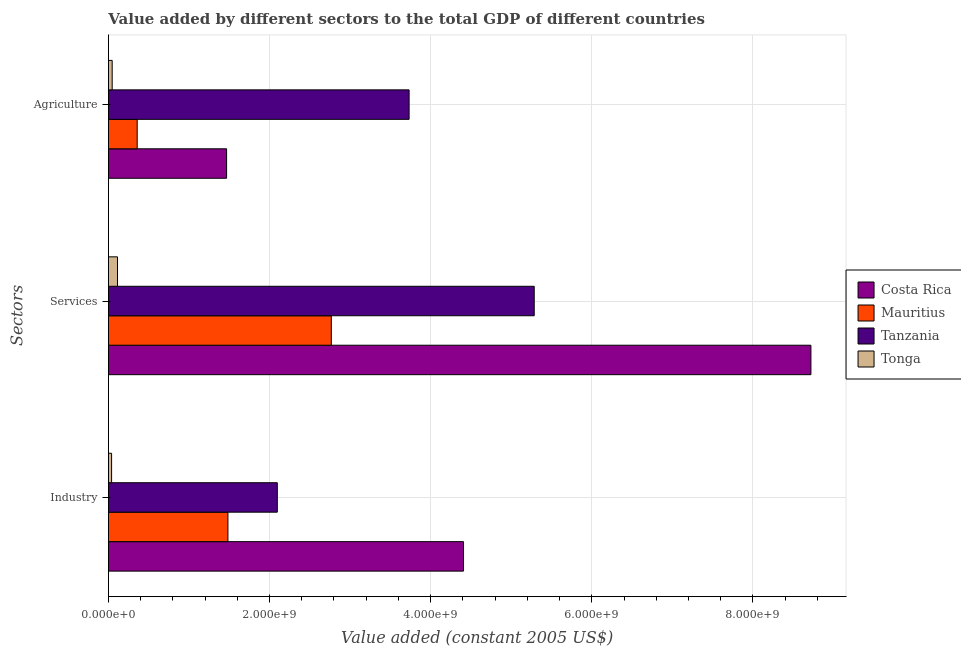How many different coloured bars are there?
Make the answer very short. 4. How many groups of bars are there?
Your response must be concise. 3. Are the number of bars per tick equal to the number of legend labels?
Provide a succinct answer. Yes. Are the number of bars on each tick of the Y-axis equal?
Give a very brief answer. Yes. How many bars are there on the 3rd tick from the top?
Your answer should be compact. 4. How many bars are there on the 3rd tick from the bottom?
Keep it short and to the point. 4. What is the label of the 2nd group of bars from the top?
Give a very brief answer. Services. What is the value added by services in Tanzania?
Ensure brevity in your answer.  5.29e+09. Across all countries, what is the maximum value added by industrial sector?
Give a very brief answer. 4.41e+09. Across all countries, what is the minimum value added by agricultural sector?
Keep it short and to the point. 4.65e+07. In which country was the value added by agricultural sector maximum?
Make the answer very short. Tanzania. In which country was the value added by services minimum?
Your answer should be very brief. Tonga. What is the total value added by industrial sector in the graph?
Make the answer very short. 8.03e+09. What is the difference between the value added by services in Mauritius and that in Tonga?
Your answer should be very brief. 2.65e+09. What is the difference between the value added by services in Mauritius and the value added by industrial sector in Costa Rica?
Offer a very short reply. -1.64e+09. What is the average value added by industrial sector per country?
Your response must be concise. 2.01e+09. What is the difference between the value added by services and value added by agricultural sector in Tonga?
Ensure brevity in your answer.  6.60e+07. In how many countries, is the value added by services greater than 1200000000 US$?
Ensure brevity in your answer.  3. What is the ratio of the value added by services in Costa Rica to that in Tonga?
Offer a terse response. 77.46. Is the value added by industrial sector in Mauritius less than that in Tonga?
Give a very brief answer. No. What is the difference between the highest and the second highest value added by services?
Your answer should be compact. 3.43e+09. What is the difference between the highest and the lowest value added by industrial sector?
Provide a short and direct response. 4.37e+09. In how many countries, is the value added by services greater than the average value added by services taken over all countries?
Your response must be concise. 2. What does the 2nd bar from the bottom in Services represents?
Provide a succinct answer. Mauritius. Is it the case that in every country, the sum of the value added by industrial sector and value added by services is greater than the value added by agricultural sector?
Offer a very short reply. Yes. How many bars are there?
Provide a succinct answer. 12. Are all the bars in the graph horizontal?
Provide a succinct answer. Yes. Where does the legend appear in the graph?
Your response must be concise. Center right. How are the legend labels stacked?
Make the answer very short. Vertical. What is the title of the graph?
Your response must be concise. Value added by different sectors to the total GDP of different countries. What is the label or title of the X-axis?
Provide a succinct answer. Value added (constant 2005 US$). What is the label or title of the Y-axis?
Make the answer very short. Sectors. What is the Value added (constant 2005 US$) of Costa Rica in Industry?
Your answer should be compact. 4.41e+09. What is the Value added (constant 2005 US$) of Mauritius in Industry?
Your response must be concise. 1.48e+09. What is the Value added (constant 2005 US$) in Tanzania in Industry?
Provide a short and direct response. 2.10e+09. What is the Value added (constant 2005 US$) of Tonga in Industry?
Make the answer very short. 3.93e+07. What is the Value added (constant 2005 US$) of Costa Rica in Services?
Provide a succinct answer. 8.72e+09. What is the Value added (constant 2005 US$) in Mauritius in Services?
Ensure brevity in your answer.  2.77e+09. What is the Value added (constant 2005 US$) in Tanzania in Services?
Your answer should be very brief. 5.29e+09. What is the Value added (constant 2005 US$) of Tonga in Services?
Make the answer very short. 1.13e+08. What is the Value added (constant 2005 US$) of Costa Rica in Agriculture?
Your answer should be very brief. 1.47e+09. What is the Value added (constant 2005 US$) of Mauritius in Agriculture?
Your response must be concise. 3.57e+08. What is the Value added (constant 2005 US$) of Tanzania in Agriculture?
Your response must be concise. 3.73e+09. What is the Value added (constant 2005 US$) of Tonga in Agriculture?
Offer a terse response. 4.65e+07. Across all Sectors, what is the maximum Value added (constant 2005 US$) in Costa Rica?
Ensure brevity in your answer.  8.72e+09. Across all Sectors, what is the maximum Value added (constant 2005 US$) in Mauritius?
Your answer should be very brief. 2.77e+09. Across all Sectors, what is the maximum Value added (constant 2005 US$) of Tanzania?
Offer a terse response. 5.29e+09. Across all Sectors, what is the maximum Value added (constant 2005 US$) in Tonga?
Give a very brief answer. 1.13e+08. Across all Sectors, what is the minimum Value added (constant 2005 US$) of Costa Rica?
Your answer should be very brief. 1.47e+09. Across all Sectors, what is the minimum Value added (constant 2005 US$) of Mauritius?
Ensure brevity in your answer.  3.57e+08. Across all Sectors, what is the minimum Value added (constant 2005 US$) of Tanzania?
Your answer should be compact. 2.10e+09. Across all Sectors, what is the minimum Value added (constant 2005 US$) of Tonga?
Your answer should be compact. 3.93e+07. What is the total Value added (constant 2005 US$) in Costa Rica in the graph?
Offer a very short reply. 1.46e+1. What is the total Value added (constant 2005 US$) in Mauritius in the graph?
Offer a very short reply. 4.61e+09. What is the total Value added (constant 2005 US$) of Tanzania in the graph?
Make the answer very short. 1.11e+1. What is the total Value added (constant 2005 US$) in Tonga in the graph?
Provide a succinct answer. 1.98e+08. What is the difference between the Value added (constant 2005 US$) in Costa Rica in Industry and that in Services?
Make the answer very short. -4.31e+09. What is the difference between the Value added (constant 2005 US$) in Mauritius in Industry and that in Services?
Ensure brevity in your answer.  -1.28e+09. What is the difference between the Value added (constant 2005 US$) of Tanzania in Industry and that in Services?
Keep it short and to the point. -3.19e+09. What is the difference between the Value added (constant 2005 US$) of Tonga in Industry and that in Services?
Offer a very short reply. -7.33e+07. What is the difference between the Value added (constant 2005 US$) in Costa Rica in Industry and that in Agriculture?
Provide a succinct answer. 2.94e+09. What is the difference between the Value added (constant 2005 US$) of Mauritius in Industry and that in Agriculture?
Ensure brevity in your answer.  1.13e+09. What is the difference between the Value added (constant 2005 US$) of Tanzania in Industry and that in Agriculture?
Provide a succinct answer. -1.64e+09. What is the difference between the Value added (constant 2005 US$) of Tonga in Industry and that in Agriculture?
Offer a very short reply. -7.25e+06. What is the difference between the Value added (constant 2005 US$) in Costa Rica in Services and that in Agriculture?
Your answer should be very brief. 7.25e+09. What is the difference between the Value added (constant 2005 US$) of Mauritius in Services and that in Agriculture?
Keep it short and to the point. 2.41e+09. What is the difference between the Value added (constant 2005 US$) of Tanzania in Services and that in Agriculture?
Offer a terse response. 1.55e+09. What is the difference between the Value added (constant 2005 US$) of Tonga in Services and that in Agriculture?
Provide a short and direct response. 6.60e+07. What is the difference between the Value added (constant 2005 US$) in Costa Rica in Industry and the Value added (constant 2005 US$) in Mauritius in Services?
Provide a short and direct response. 1.64e+09. What is the difference between the Value added (constant 2005 US$) of Costa Rica in Industry and the Value added (constant 2005 US$) of Tanzania in Services?
Keep it short and to the point. -8.78e+08. What is the difference between the Value added (constant 2005 US$) in Costa Rica in Industry and the Value added (constant 2005 US$) in Tonga in Services?
Offer a terse response. 4.30e+09. What is the difference between the Value added (constant 2005 US$) in Mauritius in Industry and the Value added (constant 2005 US$) in Tanzania in Services?
Ensure brevity in your answer.  -3.80e+09. What is the difference between the Value added (constant 2005 US$) of Mauritius in Industry and the Value added (constant 2005 US$) of Tonga in Services?
Provide a short and direct response. 1.37e+09. What is the difference between the Value added (constant 2005 US$) in Tanzania in Industry and the Value added (constant 2005 US$) in Tonga in Services?
Ensure brevity in your answer.  1.98e+09. What is the difference between the Value added (constant 2005 US$) of Costa Rica in Industry and the Value added (constant 2005 US$) of Mauritius in Agriculture?
Keep it short and to the point. 4.05e+09. What is the difference between the Value added (constant 2005 US$) in Costa Rica in Industry and the Value added (constant 2005 US$) in Tanzania in Agriculture?
Offer a very short reply. 6.75e+08. What is the difference between the Value added (constant 2005 US$) in Costa Rica in Industry and the Value added (constant 2005 US$) in Tonga in Agriculture?
Offer a terse response. 4.36e+09. What is the difference between the Value added (constant 2005 US$) in Mauritius in Industry and the Value added (constant 2005 US$) in Tanzania in Agriculture?
Your response must be concise. -2.25e+09. What is the difference between the Value added (constant 2005 US$) of Mauritius in Industry and the Value added (constant 2005 US$) of Tonga in Agriculture?
Ensure brevity in your answer.  1.44e+09. What is the difference between the Value added (constant 2005 US$) in Tanzania in Industry and the Value added (constant 2005 US$) in Tonga in Agriculture?
Provide a succinct answer. 2.05e+09. What is the difference between the Value added (constant 2005 US$) of Costa Rica in Services and the Value added (constant 2005 US$) of Mauritius in Agriculture?
Provide a succinct answer. 8.36e+09. What is the difference between the Value added (constant 2005 US$) of Costa Rica in Services and the Value added (constant 2005 US$) of Tanzania in Agriculture?
Give a very brief answer. 4.99e+09. What is the difference between the Value added (constant 2005 US$) of Costa Rica in Services and the Value added (constant 2005 US$) of Tonga in Agriculture?
Your answer should be compact. 8.67e+09. What is the difference between the Value added (constant 2005 US$) of Mauritius in Services and the Value added (constant 2005 US$) of Tanzania in Agriculture?
Your response must be concise. -9.66e+08. What is the difference between the Value added (constant 2005 US$) in Mauritius in Services and the Value added (constant 2005 US$) in Tonga in Agriculture?
Provide a short and direct response. 2.72e+09. What is the difference between the Value added (constant 2005 US$) of Tanzania in Services and the Value added (constant 2005 US$) of Tonga in Agriculture?
Keep it short and to the point. 5.24e+09. What is the average Value added (constant 2005 US$) of Costa Rica per Sectors?
Provide a short and direct response. 4.86e+09. What is the average Value added (constant 2005 US$) of Mauritius per Sectors?
Make the answer very short. 1.54e+09. What is the average Value added (constant 2005 US$) in Tanzania per Sectors?
Provide a short and direct response. 3.70e+09. What is the average Value added (constant 2005 US$) of Tonga per Sectors?
Ensure brevity in your answer.  6.61e+07. What is the difference between the Value added (constant 2005 US$) in Costa Rica and Value added (constant 2005 US$) in Mauritius in Industry?
Keep it short and to the point. 2.92e+09. What is the difference between the Value added (constant 2005 US$) in Costa Rica and Value added (constant 2005 US$) in Tanzania in Industry?
Offer a very short reply. 2.31e+09. What is the difference between the Value added (constant 2005 US$) of Costa Rica and Value added (constant 2005 US$) of Tonga in Industry?
Offer a very short reply. 4.37e+09. What is the difference between the Value added (constant 2005 US$) in Mauritius and Value added (constant 2005 US$) in Tanzania in Industry?
Your answer should be compact. -6.13e+08. What is the difference between the Value added (constant 2005 US$) in Mauritius and Value added (constant 2005 US$) in Tonga in Industry?
Provide a short and direct response. 1.44e+09. What is the difference between the Value added (constant 2005 US$) of Tanzania and Value added (constant 2005 US$) of Tonga in Industry?
Your response must be concise. 2.06e+09. What is the difference between the Value added (constant 2005 US$) in Costa Rica and Value added (constant 2005 US$) in Mauritius in Services?
Give a very brief answer. 5.95e+09. What is the difference between the Value added (constant 2005 US$) in Costa Rica and Value added (constant 2005 US$) in Tanzania in Services?
Ensure brevity in your answer.  3.43e+09. What is the difference between the Value added (constant 2005 US$) in Costa Rica and Value added (constant 2005 US$) in Tonga in Services?
Your answer should be very brief. 8.61e+09. What is the difference between the Value added (constant 2005 US$) of Mauritius and Value added (constant 2005 US$) of Tanzania in Services?
Give a very brief answer. -2.52e+09. What is the difference between the Value added (constant 2005 US$) in Mauritius and Value added (constant 2005 US$) in Tonga in Services?
Ensure brevity in your answer.  2.65e+09. What is the difference between the Value added (constant 2005 US$) of Tanzania and Value added (constant 2005 US$) of Tonga in Services?
Ensure brevity in your answer.  5.17e+09. What is the difference between the Value added (constant 2005 US$) in Costa Rica and Value added (constant 2005 US$) in Mauritius in Agriculture?
Keep it short and to the point. 1.11e+09. What is the difference between the Value added (constant 2005 US$) in Costa Rica and Value added (constant 2005 US$) in Tanzania in Agriculture?
Provide a short and direct response. -2.27e+09. What is the difference between the Value added (constant 2005 US$) in Costa Rica and Value added (constant 2005 US$) in Tonga in Agriculture?
Your answer should be compact. 1.42e+09. What is the difference between the Value added (constant 2005 US$) of Mauritius and Value added (constant 2005 US$) of Tanzania in Agriculture?
Offer a terse response. -3.38e+09. What is the difference between the Value added (constant 2005 US$) in Mauritius and Value added (constant 2005 US$) in Tonga in Agriculture?
Offer a very short reply. 3.10e+08. What is the difference between the Value added (constant 2005 US$) of Tanzania and Value added (constant 2005 US$) of Tonga in Agriculture?
Make the answer very short. 3.69e+09. What is the ratio of the Value added (constant 2005 US$) of Costa Rica in Industry to that in Services?
Your response must be concise. 0.51. What is the ratio of the Value added (constant 2005 US$) in Mauritius in Industry to that in Services?
Your answer should be compact. 0.54. What is the ratio of the Value added (constant 2005 US$) of Tanzania in Industry to that in Services?
Make the answer very short. 0.4. What is the ratio of the Value added (constant 2005 US$) of Tonga in Industry to that in Services?
Keep it short and to the point. 0.35. What is the ratio of the Value added (constant 2005 US$) of Costa Rica in Industry to that in Agriculture?
Provide a succinct answer. 3.01. What is the ratio of the Value added (constant 2005 US$) of Mauritius in Industry to that in Agriculture?
Your answer should be compact. 4.16. What is the ratio of the Value added (constant 2005 US$) in Tanzania in Industry to that in Agriculture?
Offer a terse response. 0.56. What is the ratio of the Value added (constant 2005 US$) of Tonga in Industry to that in Agriculture?
Provide a succinct answer. 0.84. What is the ratio of the Value added (constant 2005 US$) of Costa Rica in Services to that in Agriculture?
Keep it short and to the point. 5.95. What is the ratio of the Value added (constant 2005 US$) of Mauritius in Services to that in Agriculture?
Offer a terse response. 7.75. What is the ratio of the Value added (constant 2005 US$) of Tanzania in Services to that in Agriculture?
Give a very brief answer. 1.42. What is the ratio of the Value added (constant 2005 US$) of Tonga in Services to that in Agriculture?
Provide a succinct answer. 2.42. What is the difference between the highest and the second highest Value added (constant 2005 US$) of Costa Rica?
Ensure brevity in your answer.  4.31e+09. What is the difference between the highest and the second highest Value added (constant 2005 US$) in Mauritius?
Your answer should be very brief. 1.28e+09. What is the difference between the highest and the second highest Value added (constant 2005 US$) in Tanzania?
Keep it short and to the point. 1.55e+09. What is the difference between the highest and the second highest Value added (constant 2005 US$) in Tonga?
Provide a succinct answer. 6.60e+07. What is the difference between the highest and the lowest Value added (constant 2005 US$) in Costa Rica?
Give a very brief answer. 7.25e+09. What is the difference between the highest and the lowest Value added (constant 2005 US$) in Mauritius?
Provide a short and direct response. 2.41e+09. What is the difference between the highest and the lowest Value added (constant 2005 US$) of Tanzania?
Your answer should be very brief. 3.19e+09. What is the difference between the highest and the lowest Value added (constant 2005 US$) of Tonga?
Provide a succinct answer. 7.33e+07. 